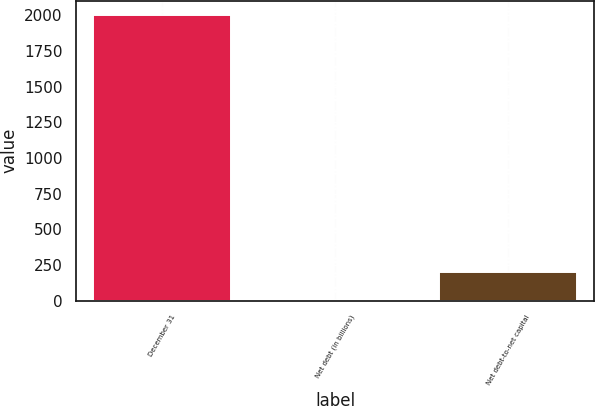Convert chart to OTSL. <chart><loc_0><loc_0><loc_500><loc_500><bar_chart><fcel>December 31<fcel>Net debt (in billions)<fcel>Net debt-to-net capital<nl><fcel>2001<fcel>3.2<fcel>202.98<nl></chart> 